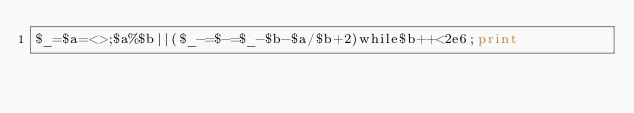Convert code to text. <code><loc_0><loc_0><loc_500><loc_500><_Perl_>$_=$a=<>;$a%$b||($_-=$-=$_-$b-$a/$b+2)while$b++<2e6;print</code> 